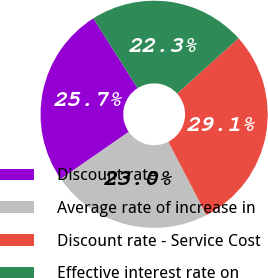<chart> <loc_0><loc_0><loc_500><loc_500><pie_chart><fcel>Discount rate<fcel>Average rate of increase in<fcel>Discount rate - Service Cost<fcel>Effective interest rate on<nl><fcel>25.66%<fcel>22.96%<fcel>29.06%<fcel>22.32%<nl></chart> 